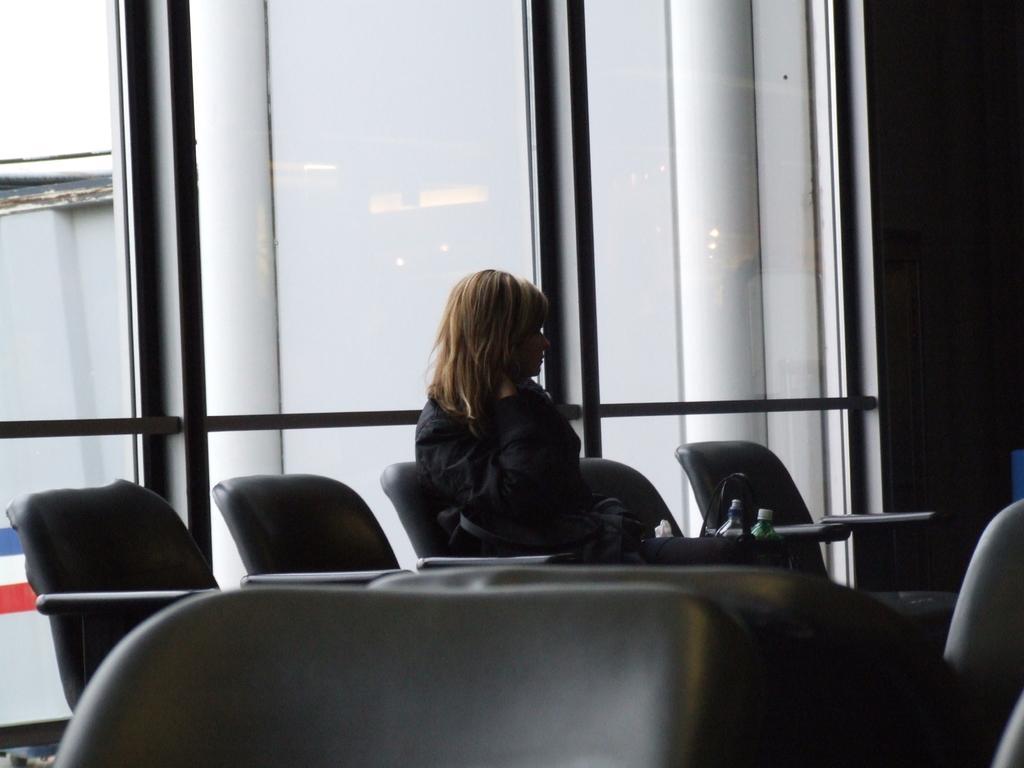Please provide a concise description of this image. Here we can see a woman is sitting on the chair, and at beside here is the hand bag and some objects on it, and at back here is the glass and here is the pillar. 